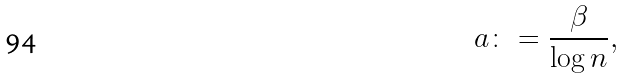<formula> <loc_0><loc_0><loc_500><loc_500>a \colon = \frac { \beta } { \log n } ,</formula> 